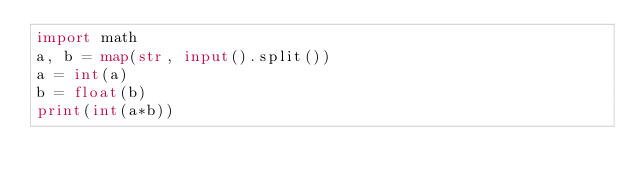Convert code to text. <code><loc_0><loc_0><loc_500><loc_500><_Python_>import math
a, b = map(str, input().split())
a = int(a)
b = float(b)
print(int(a*b))</code> 